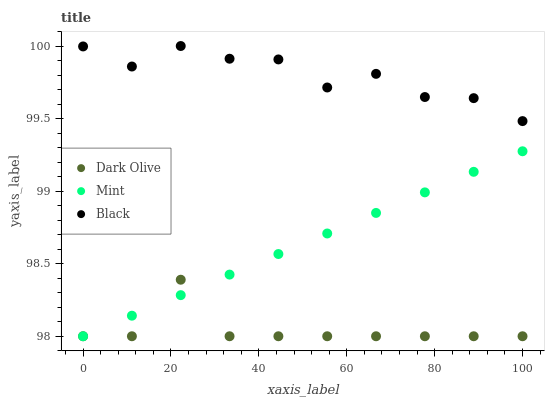Does Dark Olive have the minimum area under the curve?
Answer yes or no. Yes. Does Black have the maximum area under the curve?
Answer yes or no. Yes. Does Mint have the minimum area under the curve?
Answer yes or no. No. Does Mint have the maximum area under the curve?
Answer yes or no. No. Is Mint the smoothest?
Answer yes or no. Yes. Is Black the roughest?
Answer yes or no. Yes. Is Dark Olive the smoothest?
Answer yes or no. No. Is Dark Olive the roughest?
Answer yes or no. No. Does Dark Olive have the lowest value?
Answer yes or no. Yes. Does Black have the highest value?
Answer yes or no. Yes. Does Mint have the highest value?
Answer yes or no. No. Is Dark Olive less than Black?
Answer yes or no. Yes. Is Black greater than Mint?
Answer yes or no. Yes. Does Dark Olive intersect Mint?
Answer yes or no. Yes. Is Dark Olive less than Mint?
Answer yes or no. No. Is Dark Olive greater than Mint?
Answer yes or no. No. Does Dark Olive intersect Black?
Answer yes or no. No. 